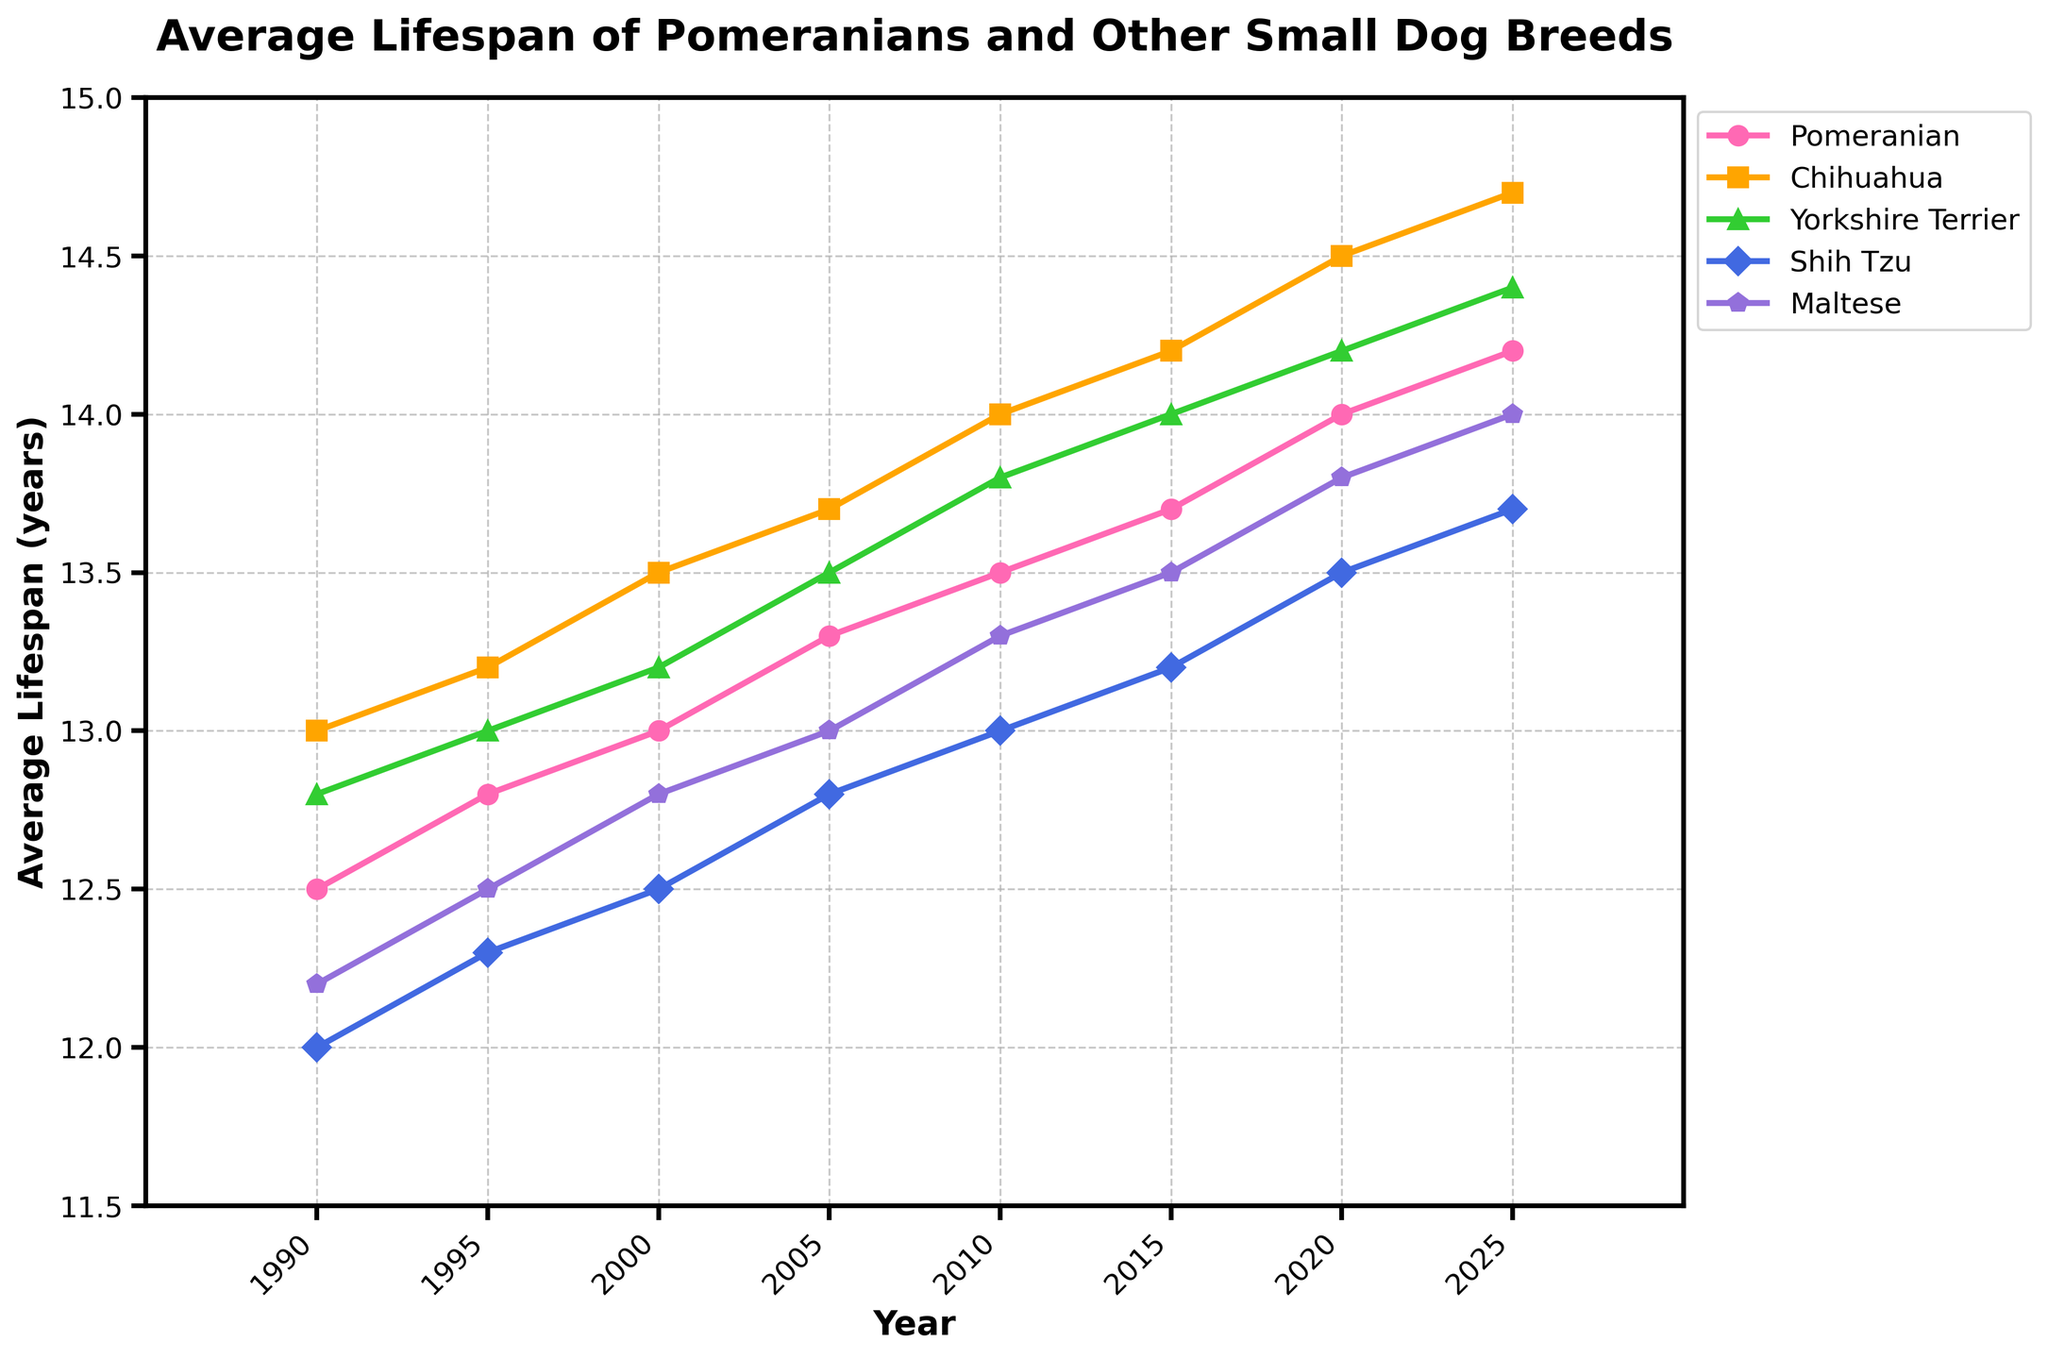What's the average lifespan of a Pomeranian in 2020 and 2025? We find the lifespan values for Pomeranians in 2020 (14.0) and 2025 (14.2). The average is (14.0 + 14.2) / 2 = 14.1
Answer: 14.1 Which breed had the highest average lifespan in 1990? By looking at the 1990 column, the Chihuahua had the highest lifespan at 13.0 years.
Answer: Chihuahua How did the lifespan of the Maltese change from 1995 to 2025? In 1995, the Maltese lifespan was 12.5 years, and in 2025, it was 14.0 years. The increase is 14.0 - 12.5 = 1.5 years.
Answer: Increased by 1.5 years Which breed had the lowest average lifespan in 2010? In 2010, the Shih Tzu had the lowest lifespan at 13.0 years.
Answer: Shih Tzu Between 2000 and 2010, which breed had the biggest increase in lifespan? We calculate the increase for each breed between 2000 and 2010:  
Pomeranian: 13.5 - 13.0 = 0.5  
Chihuahua: 14.0 - 13.5 = 0.5  
Yorkshire Terrier: 13.8 - 13.2 = 0.6  
Shih Tzu: 13.0 - 12.5 = 0.5  
Maltese: 13.3 - 12.8 = 0.5  
The Yorkshire Terrier had the biggest increase at 0.6 years.
Answer: Yorkshire Terrier In what year did the Pomeranian's lifespan first reach or exceed 14 years? The Pomeranian first reached 14 years in 2020.
Answer: 2020 Compare the lifespan trend of Pomeranians and Chihuahuas from 1990 to 2025. Both breeds show an increasing trend, but the Chihuahua consistently has a higher lifespan than the Pomeranian throughout the period.
Answer: Chihuahua has higher lifespan How does the average lifespan of Shih Tzus in 2005 compare to that of Pomeranians in 2015? In 2005, the Shih Tzu lifespan was 12.8 years, while the Pomeranian lifespan in 2015 was 13.7 years. The Pomeranian has a longer lifespan by 13.7 - 12.8 = 0.9 years.
Answer: Pomeranian by 0.9 years What color is used to represent the Pomeranian data in the plot? The Pomeranian data is represented by the color pink.
Answer: Pink 